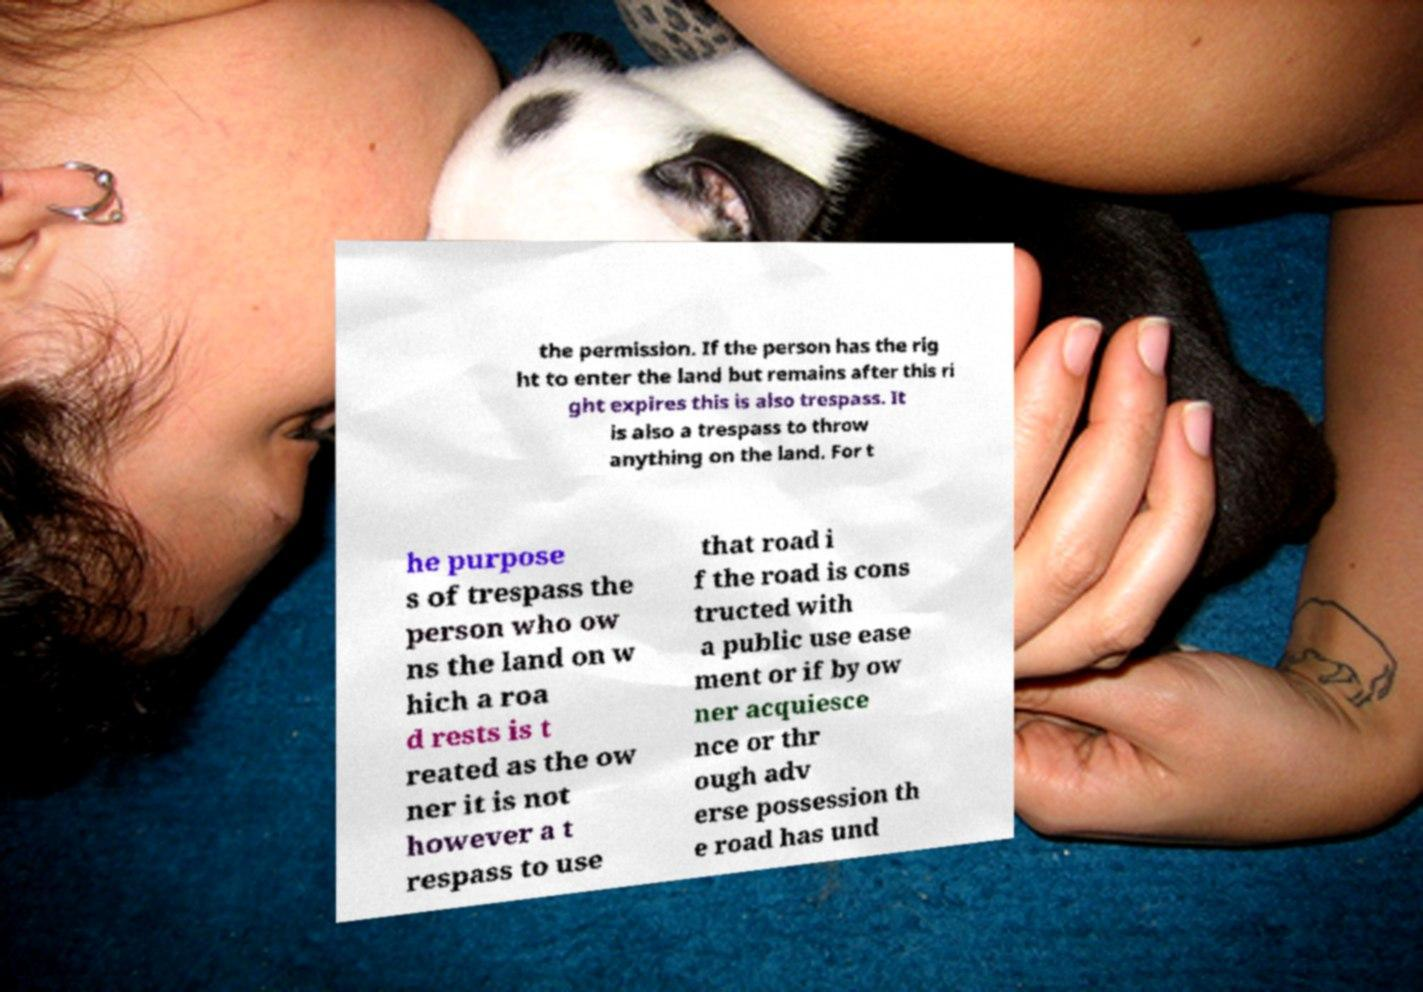Could you assist in decoding the text presented in this image and type it out clearly? the permission. If the person has the rig ht to enter the land but remains after this ri ght expires this is also trespass. It is also a trespass to throw anything on the land. For t he purpose s of trespass the person who ow ns the land on w hich a roa d rests is t reated as the ow ner it is not however a t respass to use that road i f the road is cons tructed with a public use ease ment or if by ow ner acquiesce nce or thr ough adv erse possession th e road has und 